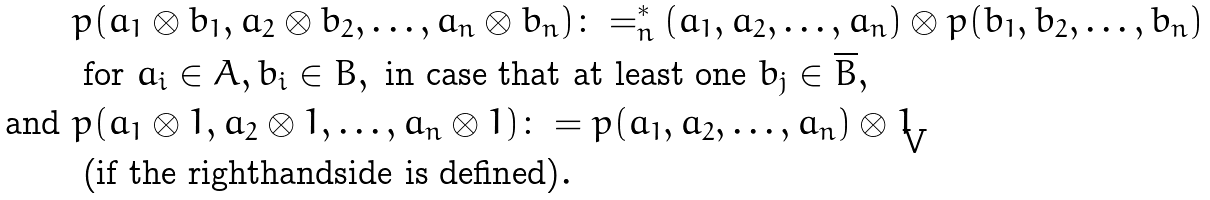<formula> <loc_0><loc_0><loc_500><loc_500>& p ( a _ { 1 } \otimes b _ { 1 } , a _ { 2 } \otimes b _ { 2 } , \dots , a _ { n } \otimes b _ { n } ) \colon = ^ { * } _ { n } ( a _ { 1 } , a _ { 2 } , \dots , a _ { n } ) \otimes p ( b _ { 1 } , b _ { 2 } , \dots , b _ { n } ) \\ & \text { for } a _ { i } \in A , b _ { i } \in B , \text { in case that at least one } b _ { j } \in \overline { B } , \\ \text {and } & p ( a _ { 1 } \otimes 1 , a _ { 2 } \otimes 1 , \dots , a _ { n } \otimes 1 ) \colon = p ( a _ { 1 } , a _ { 2 } , \dots , a _ { n } ) \otimes 1 \\ & \text { (if the righthandside is defined)} . \\</formula> 